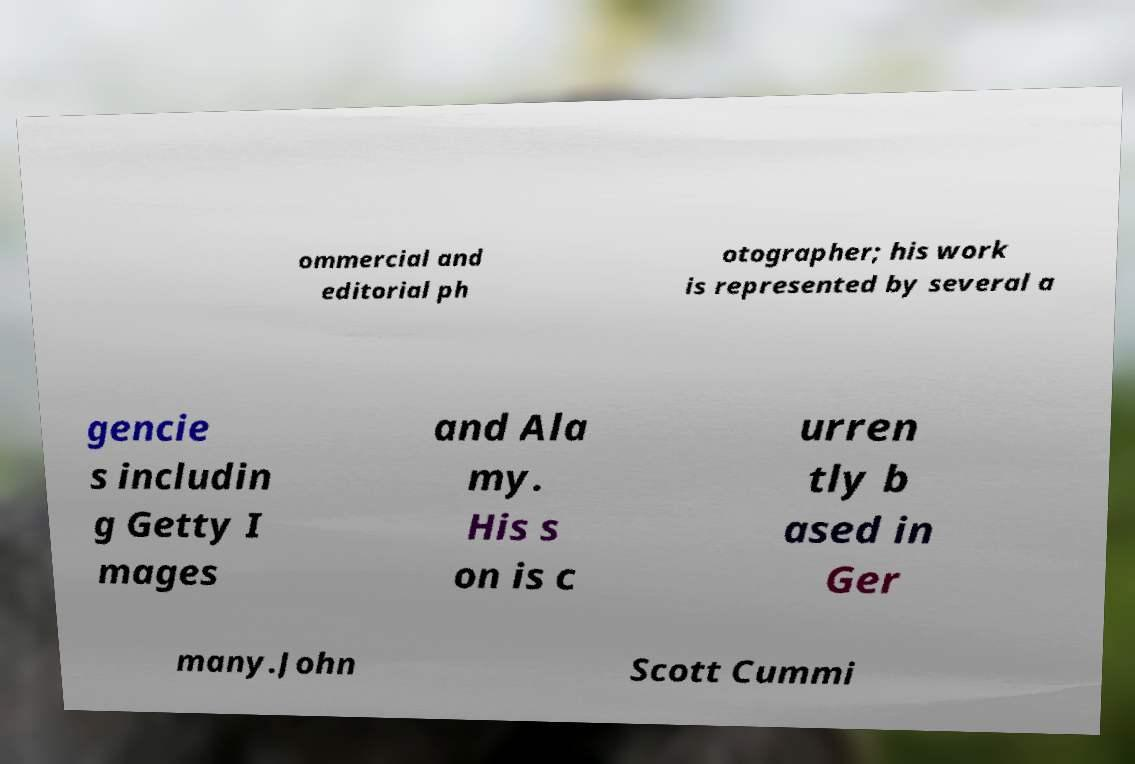Please read and relay the text visible in this image. What does it say? ommercial and editorial ph otographer; his work is represented by several a gencie s includin g Getty I mages and Ala my. His s on is c urren tly b ased in Ger many.John Scott Cummi 